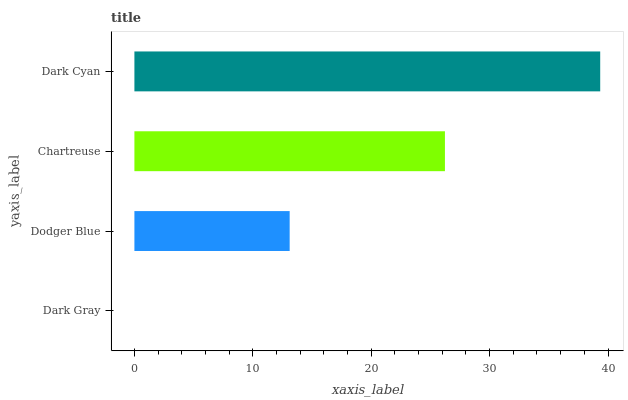Is Dark Gray the minimum?
Answer yes or no. Yes. Is Dark Cyan the maximum?
Answer yes or no. Yes. Is Dodger Blue the minimum?
Answer yes or no. No. Is Dodger Blue the maximum?
Answer yes or no. No. Is Dodger Blue greater than Dark Gray?
Answer yes or no. Yes. Is Dark Gray less than Dodger Blue?
Answer yes or no. Yes. Is Dark Gray greater than Dodger Blue?
Answer yes or no. No. Is Dodger Blue less than Dark Gray?
Answer yes or no. No. Is Chartreuse the high median?
Answer yes or no. Yes. Is Dodger Blue the low median?
Answer yes or no. Yes. Is Dark Cyan the high median?
Answer yes or no. No. Is Dark Cyan the low median?
Answer yes or no. No. 